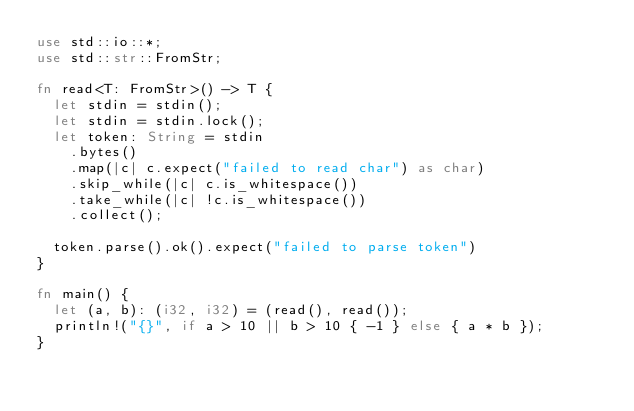<code> <loc_0><loc_0><loc_500><loc_500><_Rust_>use std::io::*;
use std::str::FromStr;

fn read<T: FromStr>() -> T {
  let stdin = stdin();
  let stdin = stdin.lock();
  let token: String = stdin
    .bytes()
    .map(|c| c.expect("failed to read char") as char) 
    .skip_while(|c| c.is_whitespace())
    .take_while(|c| !c.is_whitespace())
    .collect();
    
  token.parse().ok().expect("failed to parse token")
}

fn main() {
  let (a, b): (i32, i32) = (read(), read());
  println!("{}", if a > 10 || b > 10 { -1 } else { a * b });
}</code> 